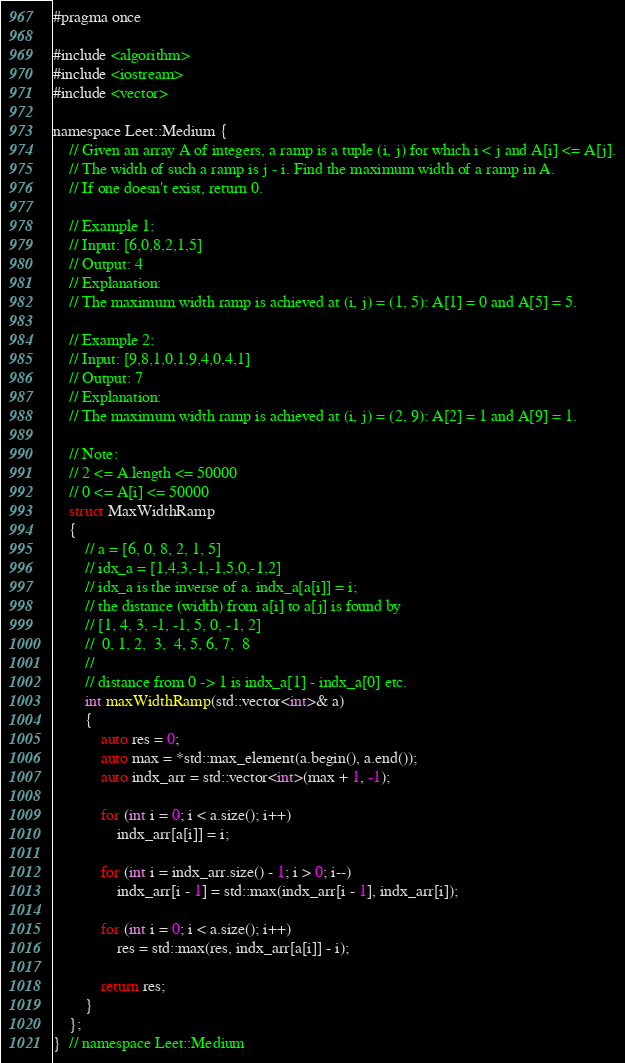Convert code to text. <code><loc_0><loc_0><loc_500><loc_500><_C_>#pragma once

#include <algorithm>
#include <iostream>
#include <vector>

namespace Leet::Medium {
    // Given an array A of integers, a ramp is a tuple (i, j) for which i < j and A[i] <= A[j].
    // The width of such a ramp is j - i. Find the maximum width of a ramp in A.
    // If one doesn't exist, return 0.

    // Example 1:
    // Input: [6,0,8,2,1,5]
    // Output: 4
    // Explanation:
    // The maximum width ramp is achieved at (i, j) = (1, 5): A[1] = 0 and A[5] = 5.

    // Example 2:
    // Input: [9,8,1,0,1,9,4,0,4,1]
    // Output: 7
    // Explanation:
    // The maximum width ramp is achieved at (i, j) = (2, 9): A[2] = 1 and A[9] = 1.

    // Note:
    // 2 <= A.length <= 50000
    // 0 <= A[i] <= 50000
    struct MaxWidthRamp
    {
        // a = [6, 0, 8, 2, 1, 5]
        // idx_a = [1,4,3,-1,-1,5,0,-1,2]
        // idx_a is the inverse of a. indx_a[a[i]] = i;
        // the distance (width) from a[i] to a[j] is found by
        // [1, 4, 3, -1, -1, 5, 0, -1, 2]
        //  0, 1, 2,  3,  4, 5, 6, 7,  8
        //
        // distance from 0 -> 1 is indx_a[1] - indx_a[0] etc.
        int maxWidthRamp(std::vector<int>& a)
        {
            auto res = 0;
            auto max = *std::max_element(a.begin(), a.end());
            auto indx_arr = std::vector<int>(max + 1, -1);

            for (int i = 0; i < a.size(); i++)
                indx_arr[a[i]] = i;

            for (int i = indx_arr.size() - 1; i > 0; i--)
                indx_arr[i - 1] = std::max(indx_arr[i - 1], indx_arr[i]);

            for (int i = 0; i < a.size(); i++)
                res = std::max(res, indx_arr[a[i]] - i);

            return res;
        }
    };
}  // namespace Leet::Medium
</code> 